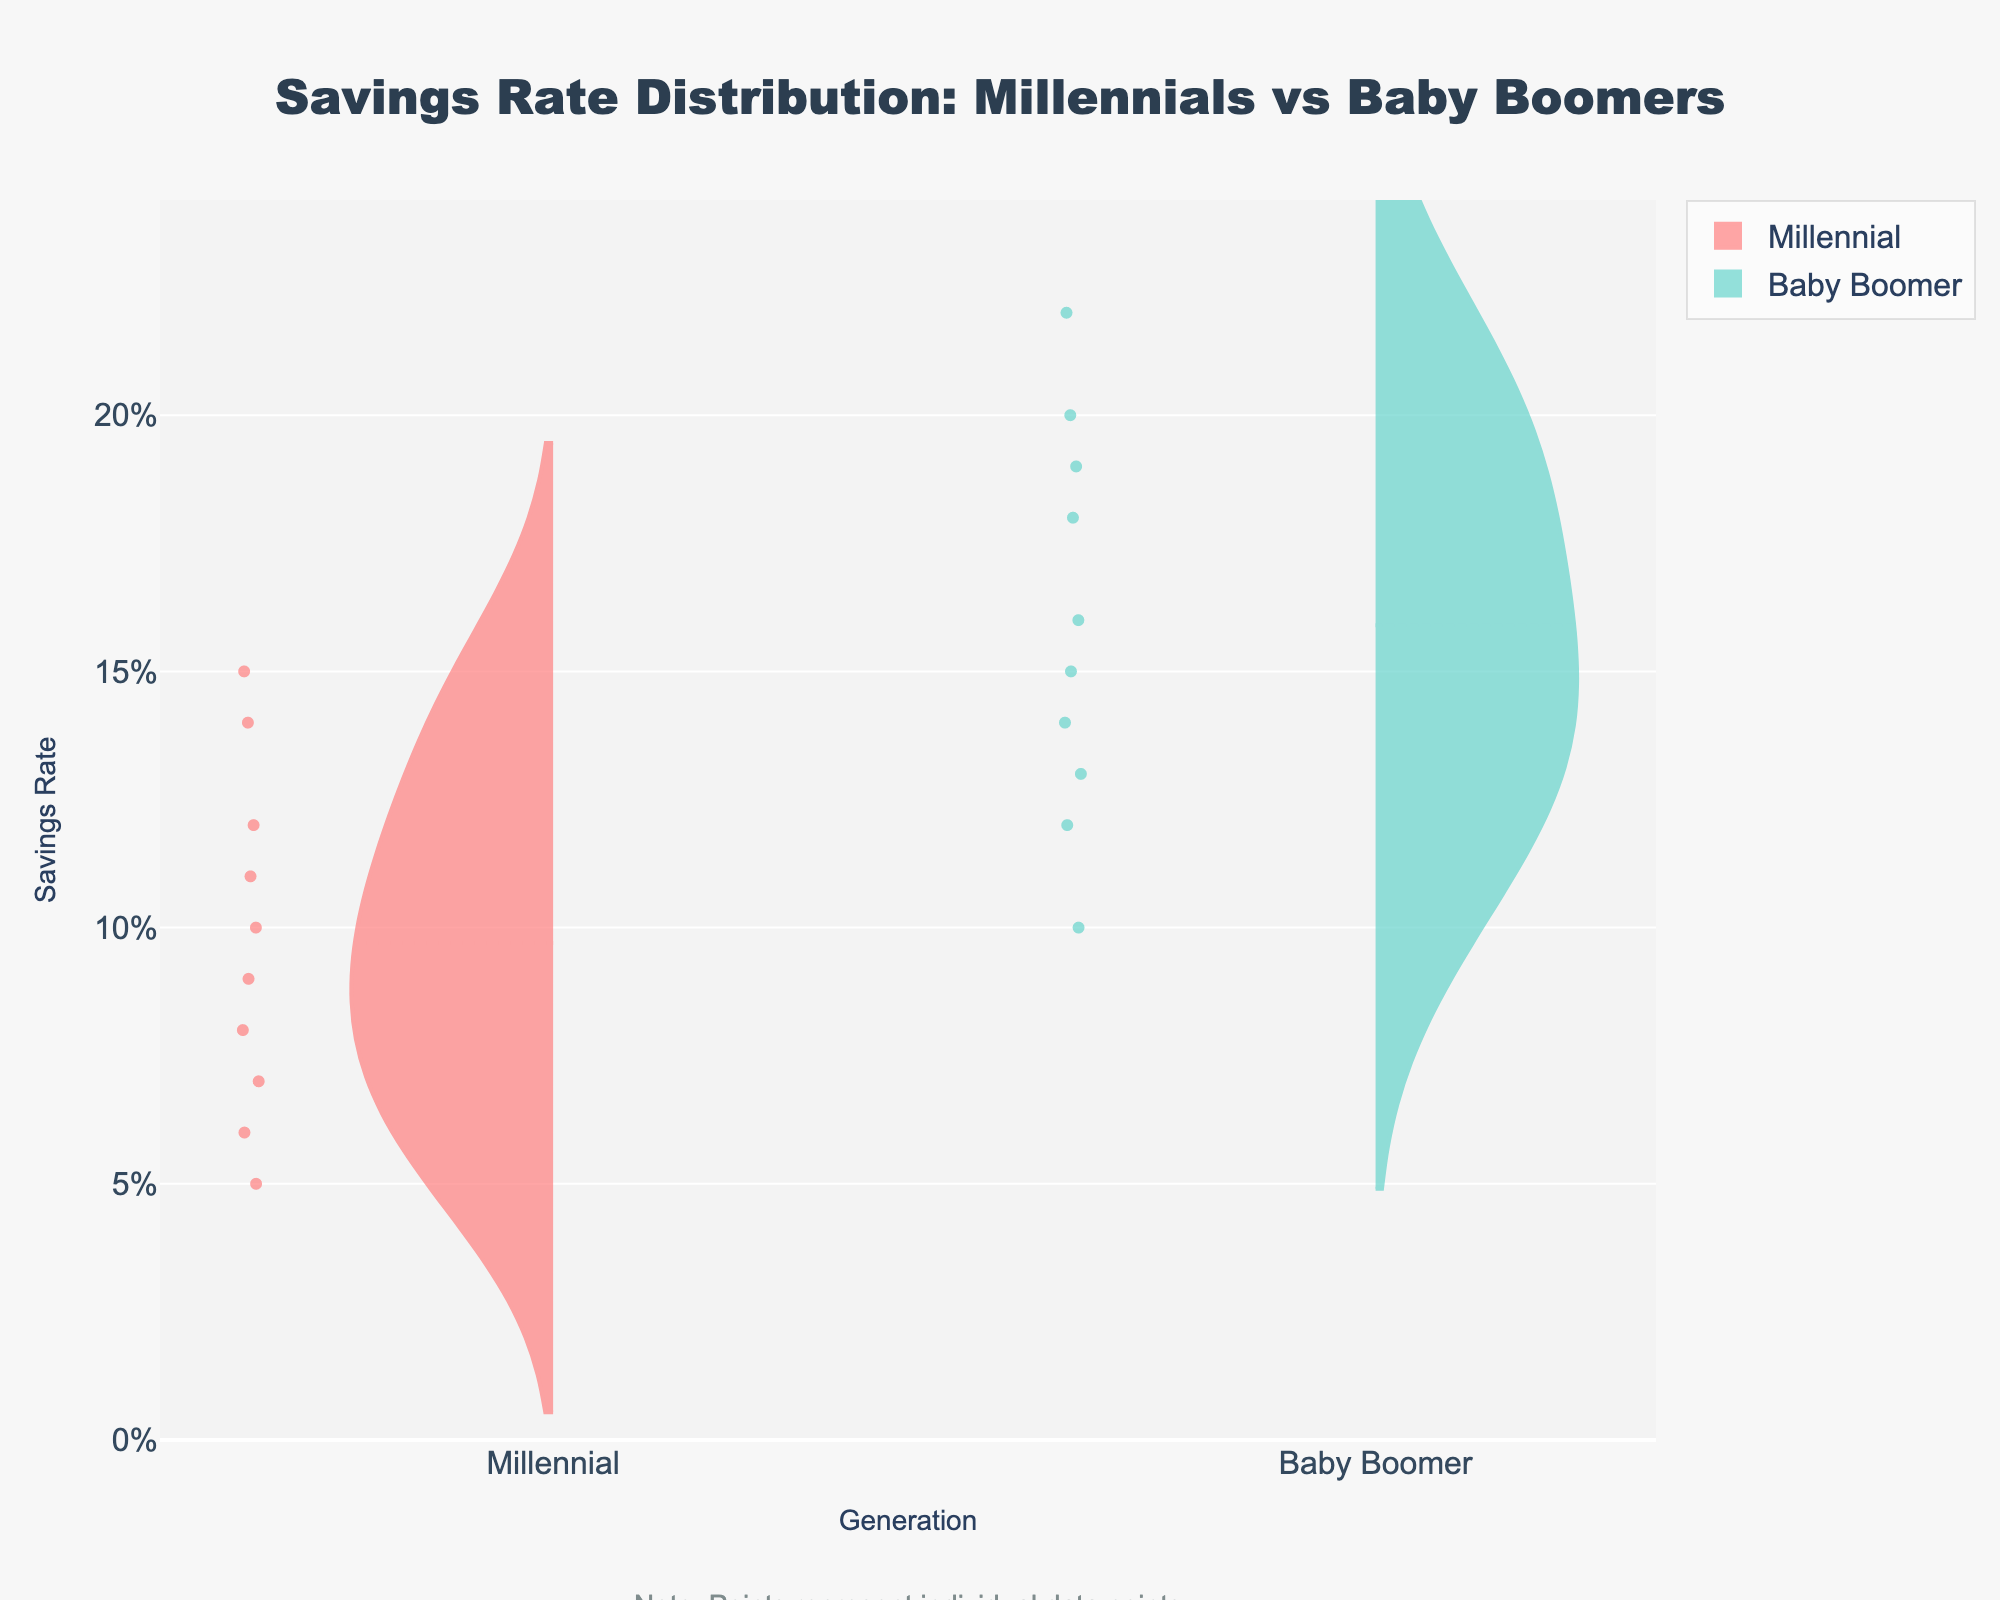what does the title of the figure say? The title is usually located at the top of the figure and provides a concise description of what the figure is about. In this case, it should describe the savings rate distributions for Millennials and Baby Boomers.
Answer: Savings Rate Distribution: Millennials vs Baby Boomers what do the x-axis labels represent? The x-axis labels indicate the categories being compared in the plot. In this case, they show the two generations being compared.
Answer: Generation what does the y-axis represent and what's its unit? The y-axis represents the savings rate and the unit is percentage, as shown by the tick format on the y-axis.
Answer: Savings Rate, Percentage which color represents Millennials? The color used for the Millennials' side of the violin plot can be seen directly in the figure. It is a red or pinkish color.
Answer: Red which generation has a wider distribution of savings rates? To determine which generation has a wider distribution, you can observe the spread of the data points and the shape of the violin plots. The wider and more extended distribution will show more variability in savings rates.
Answer: Baby Boomers what does the central line within the violins represent? The central line in the violin plots represents the mean savings rate for each generation.
Answer: Mean savings rate which generation has a higher mean savings rate? The mean can be found by looking at the central line within each violin, which represents the average savings rate. The higher mean will be at a higher y-axis value.
Answer: Baby Boomers how many data points are represented in the figure for each generation? Each dot within the violin plot represents an individual data point. Counting these dots for each generation will give the total number of data points.
Answer: 10 for each generation which generation shows a potential outlier in savings rate? Outliers can usually be seen as individual points that are far from the bulk of the data distribution. Comparing both plots will show if there are any singular points that stand out.
Answer: Baby Boomers which has a higher maximum savings rate, Millennials or Baby Boomers? The maximum savings rate is the highest value on the y-axis reached by the violin plots. Compare the topmost points of each plot.
Answer: Baby Boomers 